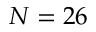Convert formula to latex. <formula><loc_0><loc_0><loc_500><loc_500>N = 2 6</formula> 